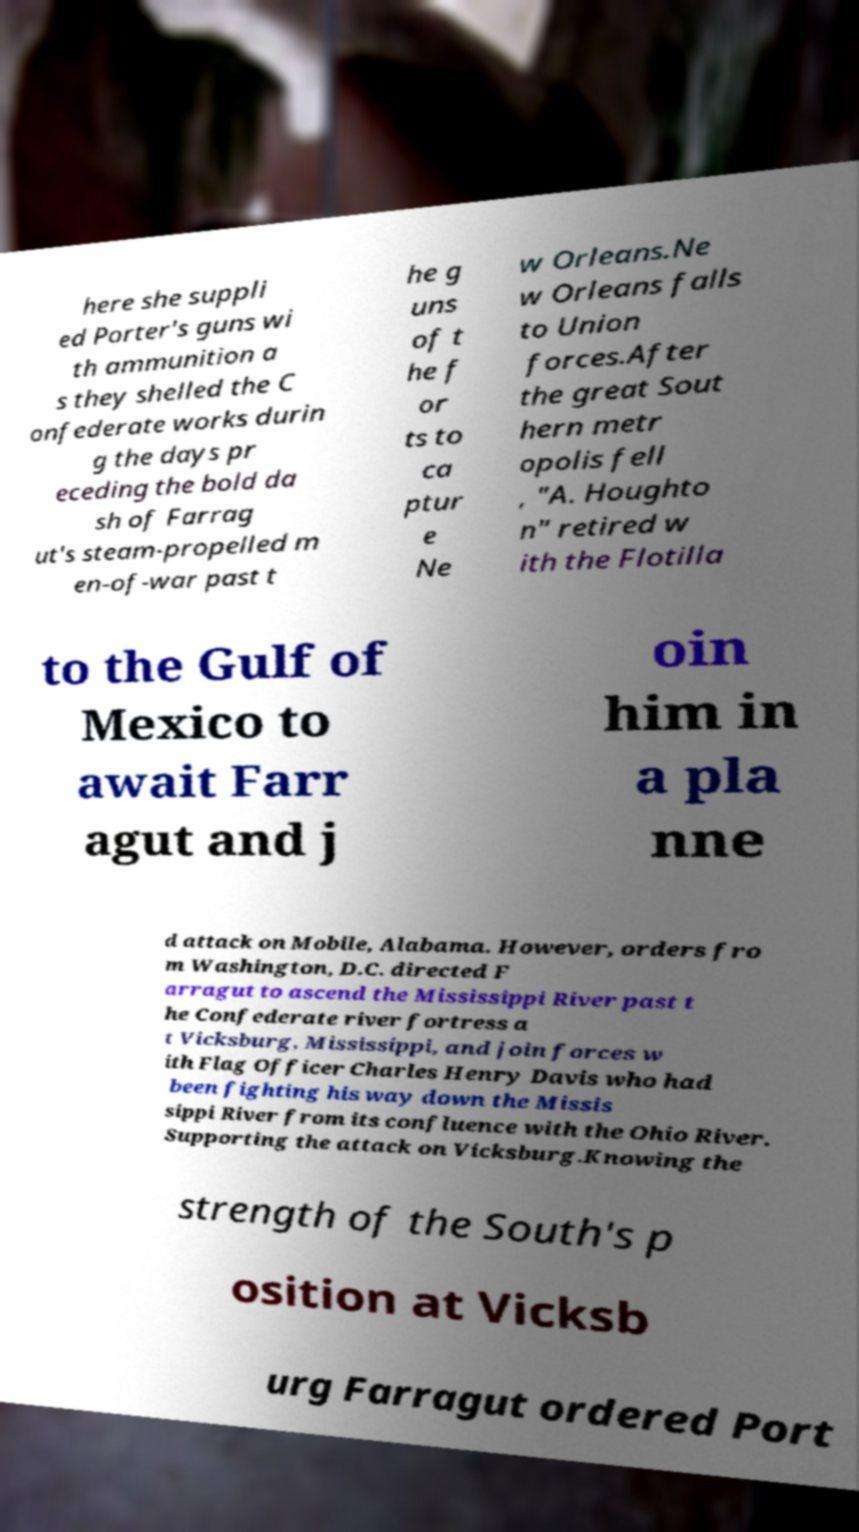Please read and relay the text visible in this image. What does it say? here she suppli ed Porter's guns wi th ammunition a s they shelled the C onfederate works durin g the days pr eceding the bold da sh of Farrag ut's steam-propelled m en-of-war past t he g uns of t he f or ts to ca ptur e Ne w Orleans.Ne w Orleans falls to Union forces.After the great Sout hern metr opolis fell , "A. Houghto n" retired w ith the Flotilla to the Gulf of Mexico to await Farr agut and j oin him in a pla nne d attack on Mobile, Alabama. However, orders fro m Washington, D.C. directed F arragut to ascend the Mississippi River past t he Confederate river fortress a t Vicksburg, Mississippi, and join forces w ith Flag Officer Charles Henry Davis who had been fighting his way down the Missis sippi River from its confluence with the Ohio River. Supporting the attack on Vicksburg.Knowing the strength of the South's p osition at Vicksb urg Farragut ordered Port 